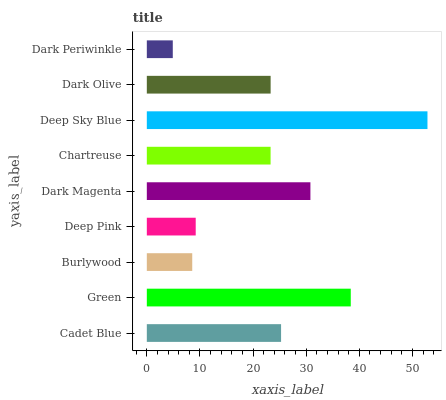Is Dark Periwinkle the minimum?
Answer yes or no. Yes. Is Deep Sky Blue the maximum?
Answer yes or no. Yes. Is Green the minimum?
Answer yes or no. No. Is Green the maximum?
Answer yes or no. No. Is Green greater than Cadet Blue?
Answer yes or no. Yes. Is Cadet Blue less than Green?
Answer yes or no. Yes. Is Cadet Blue greater than Green?
Answer yes or no. No. Is Green less than Cadet Blue?
Answer yes or no. No. Is Dark Olive the high median?
Answer yes or no. Yes. Is Dark Olive the low median?
Answer yes or no. Yes. Is Burlywood the high median?
Answer yes or no. No. Is Burlywood the low median?
Answer yes or no. No. 